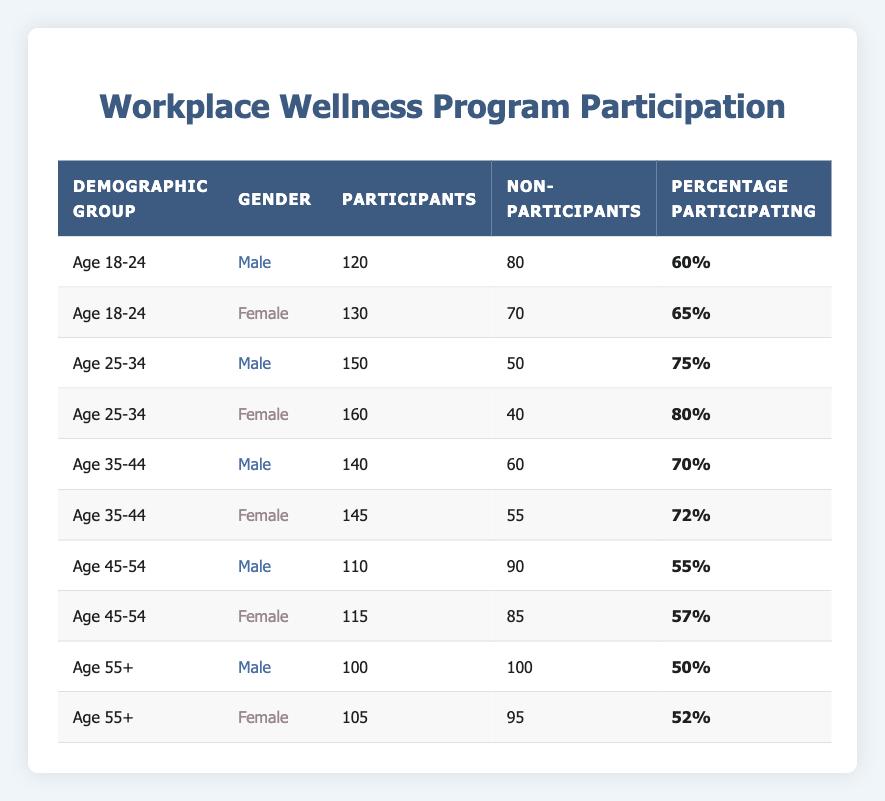What is the highest percentage of participation in the workplace wellness program by gender? The highest percentage of participation among males is 75%, which occurs in the Age 25-34 group. For females, the highest percentage is 80%, also in the Age 25-34 group. Thus, the overall highest participation is 80% for females.
Answer: 80% What is the total number of participants aged 45-54? For males, there are 110 participants, and for females, there are 115 participants in the Age 45-54 group. Adding these gives 110 + 115 = 225 participants in total for this age group.
Answer: 225 Are there more participants than non-participants in the Age 35-44 demographic group? In the Age 35-44 group, males have 140 participants and 60 non-participants, while females have 145 participants and 55 non-participants. Both genders have more participants than non-participants: 140 > 60 and 145 > 55.
Answer: Yes What is the average percentage of participation for each age group? The percentages for each age group are as follows: Age 18-24: (60 + 65) / 2 = 62.5%, Age 25-34: (75 + 80) / 2 = 77.5%, Age 35-44: (70 + 72) / 2 = 71%, Age 45-54: (55 + 57) / 2 = 56%, Age 55+: (50 + 52) / 2 = 51%. The averages are about 62.5%, 77.5%, 71%, 56%, and 51% respectively.
Answer: Age 18-24: 62.5%, Age 25-34: 77.5%, Age 35-44: 71%, Age 45-54: 56%, Age 55+: 51% Which gender within the Age 55+ demographic has a higher percentage participating in the wellness program? For Age 55+, males have a participation percentage of 50%, while females have a participation percentage of 52%. Comparing these, 52% > 50%, thus females have a higher percentage participating.
Answer: Females How does the participation rate change from Age 18-24 to Age 55+ for males? In the Age 18-24 group, males have 60% participation. In the Age 55+ group, they have 50%. The change can be found by taking the difference: 60% - 50% = 10%. Thus, the participation rate decreases by 10%.
Answer: Decreases by 10% 